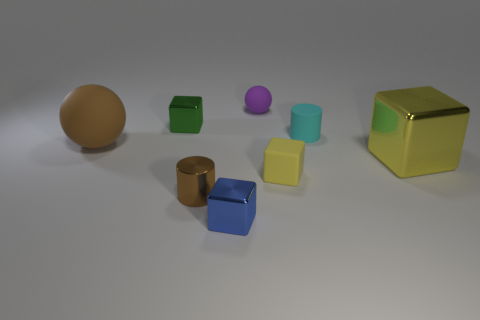The thing that is behind the tiny green metal thing on the left side of the purple object is what shape?
Give a very brief answer. Sphere. There is a large rubber sphere; does it have the same color as the shiny object that is behind the big sphere?
Offer a very short reply. No. What is the shape of the large yellow thing?
Offer a terse response. Cube. There is a sphere that is on the left side of the metal object that is behind the tiny cyan matte object; what is its size?
Keep it short and to the point. Large. Is the number of tiny cyan objects left of the tiny green block the same as the number of purple matte objects in front of the big yellow block?
Offer a terse response. Yes. What is the material of the small object that is left of the tiny blue cube and to the right of the tiny green thing?
Your response must be concise. Metal. Do the blue thing and the yellow cube that is to the right of the matte cube have the same size?
Ensure brevity in your answer.  No. How many other things are there of the same color as the large metallic block?
Make the answer very short. 1. Are there more big brown spheres that are to the left of the large brown thing than small purple matte spheres?
Ensure brevity in your answer.  No. There is a large thing that is left of the purple sphere that is behind the small block in front of the yellow rubber cube; what is its color?
Give a very brief answer. Brown. 